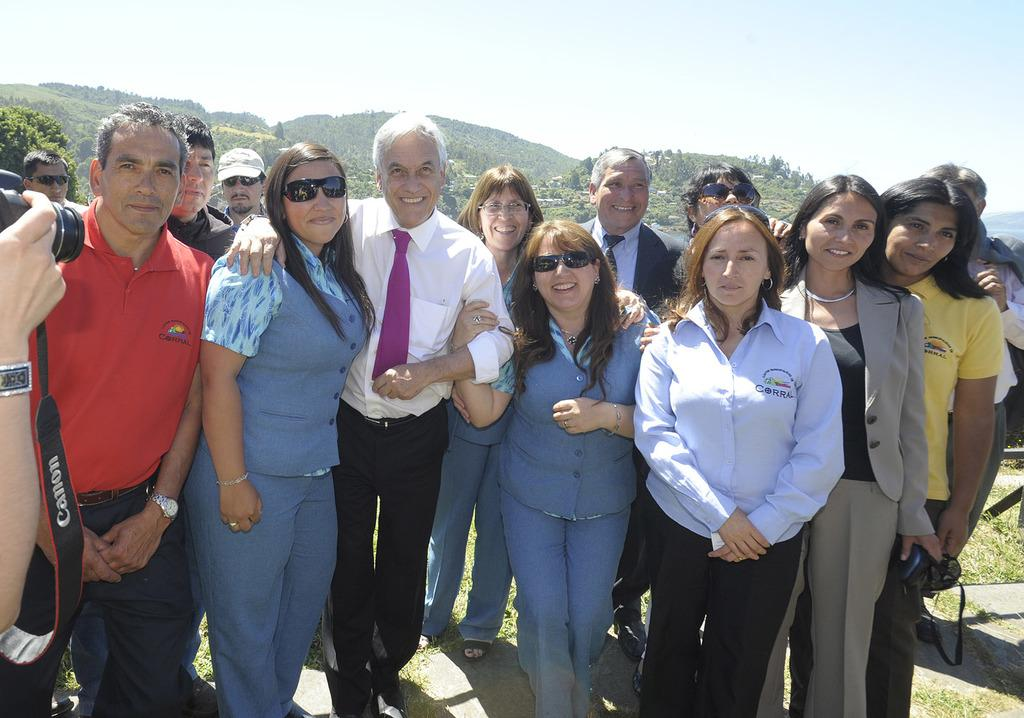How many people are present in the image? There are many persons standing on the ground in the image. What can be seen in the background of the image? There are hills, trees, houses, and the sky visible in the background of the image. What type of stocking is being worn by the flock of sheep in the image? There are no sheep or stockings present in the image. Is there a crook visible in the image? There is no crook present in the image. 